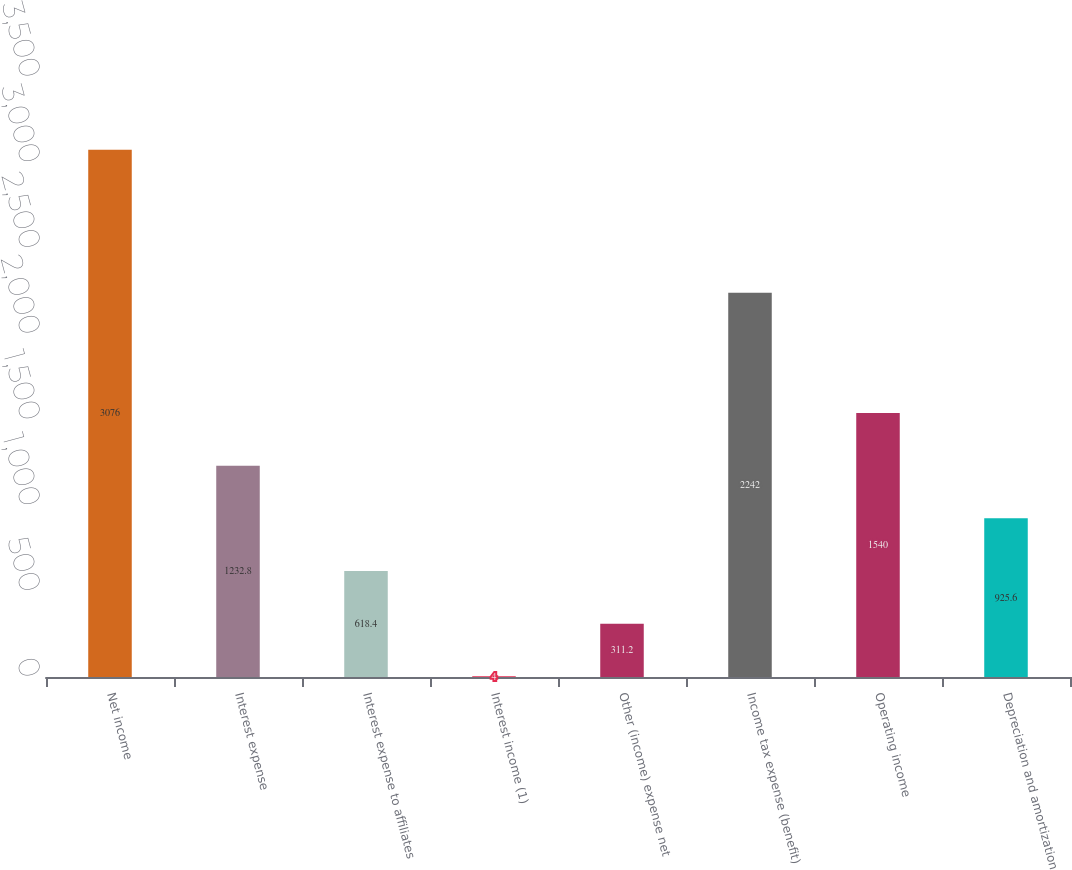Convert chart. <chart><loc_0><loc_0><loc_500><loc_500><bar_chart><fcel>Net income<fcel>Interest expense<fcel>Interest expense to affiliates<fcel>Interest income (1)<fcel>Other (income) expense net<fcel>Income tax expense (benefit)<fcel>Operating income<fcel>Depreciation and amortization<nl><fcel>3076<fcel>1232.8<fcel>618.4<fcel>4<fcel>311.2<fcel>2242<fcel>1540<fcel>925.6<nl></chart> 